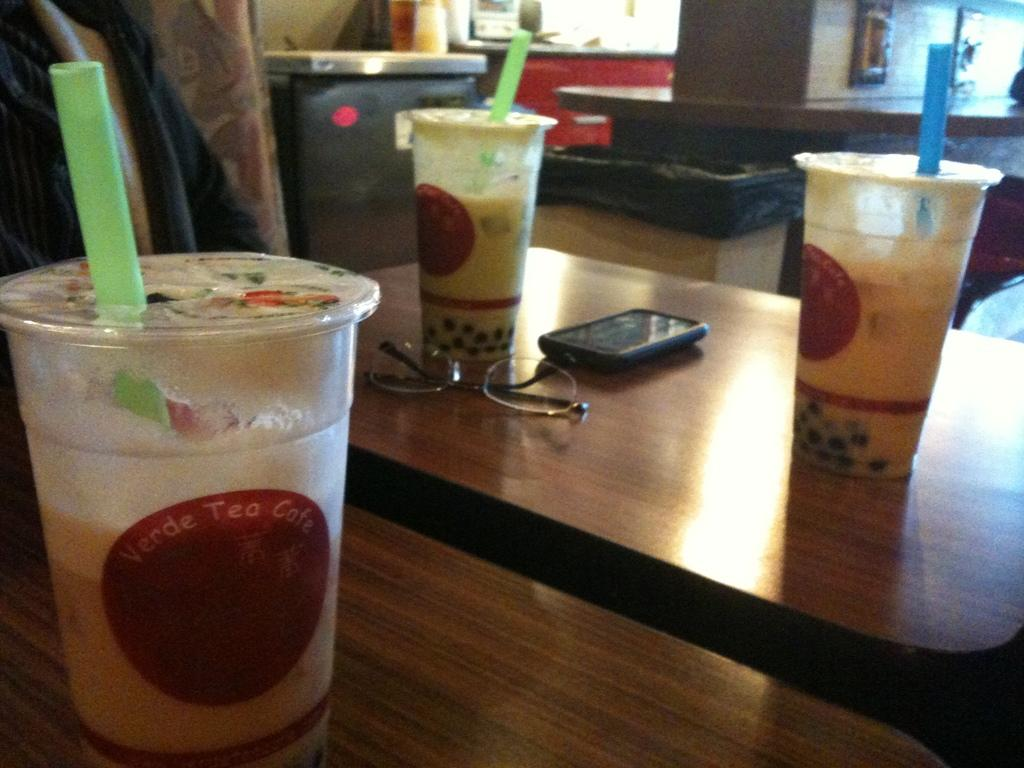<image>
Provide a brief description of the given image. three cups of bubble tea of Verde Tea Cafe 